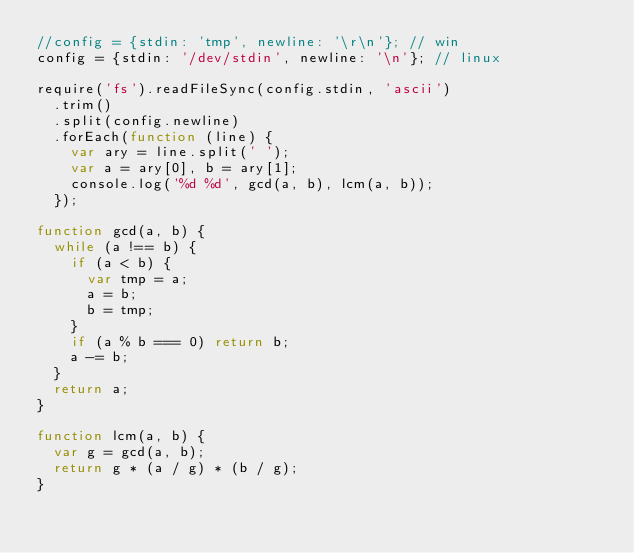<code> <loc_0><loc_0><loc_500><loc_500><_JavaScript_>//config = {stdin: 'tmp', newline: '\r\n'}; // win
config = {stdin: '/dev/stdin', newline: '\n'}; // linux

require('fs').readFileSync(config.stdin, 'ascii')
	.trim()
	.split(config.newline)
	.forEach(function (line) {
		var ary = line.split(' ');
		var a = ary[0], b = ary[1];
		console.log('%d %d', gcd(a, b), lcm(a, b));
	});

function gcd(a, b) {
	while (a !== b) {
		if (a < b) {
			var tmp = a;
			a = b;
			b = tmp;
		}
		if (a % b === 0) return b;
		a -= b;
	}
	return a;
}

function lcm(a, b) {
	var g = gcd(a, b);
	return g * (a / g) * (b / g);
}</code> 